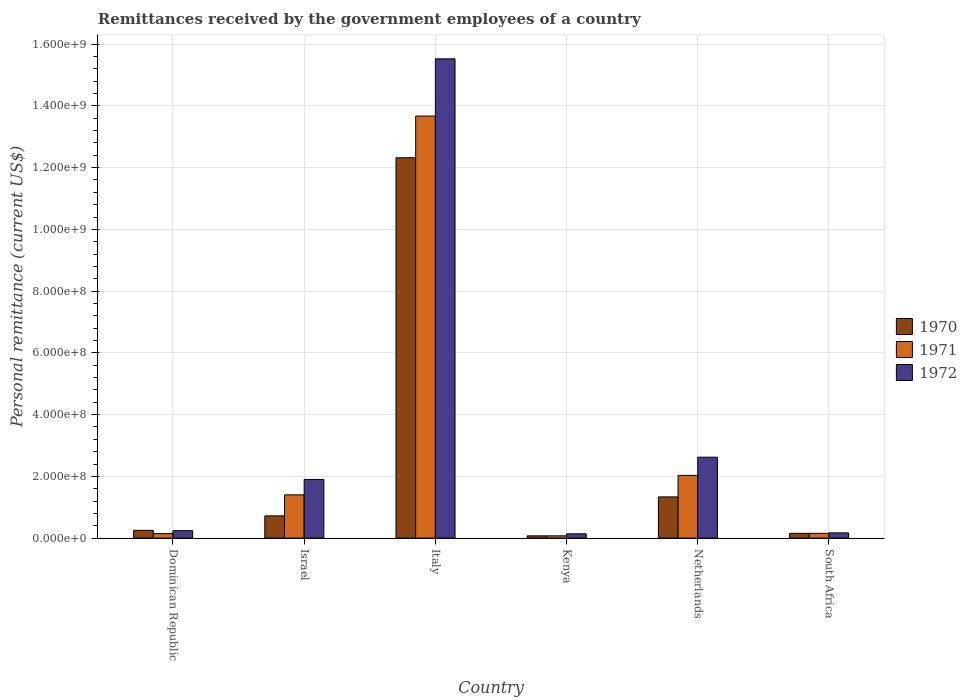How many different coloured bars are there?
Your answer should be very brief. 3. How many groups of bars are there?
Give a very brief answer. 6. Are the number of bars per tick equal to the number of legend labels?
Offer a very short reply. Yes. What is the label of the 1st group of bars from the left?
Your answer should be very brief. Dominican Republic. In how many cases, is the number of bars for a given country not equal to the number of legend labels?
Keep it short and to the point. 0. What is the remittances received by the government employees in 1972 in Israel?
Offer a very short reply. 1.90e+08. Across all countries, what is the maximum remittances received by the government employees in 1971?
Offer a very short reply. 1.37e+09. Across all countries, what is the minimum remittances received by the government employees in 1971?
Your answer should be compact. 7.26e+06. In which country was the remittances received by the government employees in 1972 maximum?
Provide a succinct answer. Italy. In which country was the remittances received by the government employees in 1970 minimum?
Ensure brevity in your answer.  Kenya. What is the total remittances received by the government employees in 1970 in the graph?
Offer a very short reply. 1.49e+09. What is the difference between the remittances received by the government employees in 1972 in Italy and that in South Africa?
Your answer should be compact. 1.54e+09. What is the difference between the remittances received by the government employees in 1970 in South Africa and the remittances received by the government employees in 1972 in Italy?
Your answer should be very brief. -1.54e+09. What is the average remittances received by the government employees in 1972 per country?
Provide a succinct answer. 3.43e+08. What is the difference between the remittances received by the government employees of/in 1971 and remittances received by the government employees of/in 1972 in South Africa?
Keep it short and to the point. -1.49e+06. In how many countries, is the remittances received by the government employees in 1970 greater than 760000000 US$?
Your answer should be very brief. 1. What is the ratio of the remittances received by the government employees in 1972 in Israel to that in Italy?
Offer a terse response. 0.12. Is the difference between the remittances received by the government employees in 1971 in Israel and Netherlands greater than the difference between the remittances received by the government employees in 1972 in Israel and Netherlands?
Make the answer very short. Yes. What is the difference between the highest and the second highest remittances received by the government employees in 1972?
Provide a succinct answer. -7.20e+07. What is the difference between the highest and the lowest remittances received by the government employees in 1971?
Make the answer very short. 1.36e+09. Is the sum of the remittances received by the government employees in 1970 in Dominican Republic and South Africa greater than the maximum remittances received by the government employees in 1971 across all countries?
Provide a short and direct response. No. Is it the case that in every country, the sum of the remittances received by the government employees in 1970 and remittances received by the government employees in 1972 is greater than the remittances received by the government employees in 1971?
Give a very brief answer. Yes. Are all the bars in the graph horizontal?
Offer a terse response. No. Does the graph contain any zero values?
Your answer should be compact. No. How many legend labels are there?
Your answer should be compact. 3. What is the title of the graph?
Make the answer very short. Remittances received by the government employees of a country. What is the label or title of the Y-axis?
Your answer should be very brief. Personal remittance (current US$). What is the Personal remittance (current US$) of 1970 in Dominican Republic?
Your answer should be compact. 2.51e+07. What is the Personal remittance (current US$) of 1971 in Dominican Republic?
Provide a succinct answer. 1.45e+07. What is the Personal remittance (current US$) in 1972 in Dominican Republic?
Provide a succinct answer. 2.40e+07. What is the Personal remittance (current US$) in 1970 in Israel?
Keep it short and to the point. 7.20e+07. What is the Personal remittance (current US$) in 1971 in Israel?
Keep it short and to the point. 1.40e+08. What is the Personal remittance (current US$) in 1972 in Israel?
Keep it short and to the point. 1.90e+08. What is the Personal remittance (current US$) in 1970 in Italy?
Offer a very short reply. 1.23e+09. What is the Personal remittance (current US$) of 1971 in Italy?
Give a very brief answer. 1.37e+09. What is the Personal remittance (current US$) of 1972 in Italy?
Provide a succinct answer. 1.55e+09. What is the Personal remittance (current US$) in 1970 in Kenya?
Ensure brevity in your answer.  7.26e+06. What is the Personal remittance (current US$) of 1971 in Kenya?
Ensure brevity in your answer.  7.26e+06. What is the Personal remittance (current US$) of 1972 in Kenya?
Offer a very short reply. 1.39e+07. What is the Personal remittance (current US$) of 1970 in Netherlands?
Your answer should be compact. 1.33e+08. What is the Personal remittance (current US$) of 1971 in Netherlands?
Offer a very short reply. 2.03e+08. What is the Personal remittance (current US$) of 1972 in Netherlands?
Provide a succinct answer. 2.62e+08. What is the Personal remittance (current US$) in 1970 in South Africa?
Keep it short and to the point. 1.54e+07. What is the Personal remittance (current US$) in 1971 in South Africa?
Your answer should be compact. 1.54e+07. What is the Personal remittance (current US$) of 1972 in South Africa?
Offer a terse response. 1.69e+07. Across all countries, what is the maximum Personal remittance (current US$) of 1970?
Make the answer very short. 1.23e+09. Across all countries, what is the maximum Personal remittance (current US$) in 1971?
Ensure brevity in your answer.  1.37e+09. Across all countries, what is the maximum Personal remittance (current US$) in 1972?
Offer a very short reply. 1.55e+09. Across all countries, what is the minimum Personal remittance (current US$) in 1970?
Give a very brief answer. 7.26e+06. Across all countries, what is the minimum Personal remittance (current US$) of 1971?
Ensure brevity in your answer.  7.26e+06. Across all countries, what is the minimum Personal remittance (current US$) in 1972?
Offer a very short reply. 1.39e+07. What is the total Personal remittance (current US$) of 1970 in the graph?
Offer a terse response. 1.49e+09. What is the total Personal remittance (current US$) of 1971 in the graph?
Provide a succinct answer. 1.75e+09. What is the total Personal remittance (current US$) of 1972 in the graph?
Provide a succinct answer. 2.06e+09. What is the difference between the Personal remittance (current US$) in 1970 in Dominican Republic and that in Israel?
Your answer should be very brief. -4.69e+07. What is the difference between the Personal remittance (current US$) of 1971 in Dominican Republic and that in Israel?
Your answer should be compact. -1.26e+08. What is the difference between the Personal remittance (current US$) in 1972 in Dominican Republic and that in Israel?
Offer a terse response. -1.66e+08. What is the difference between the Personal remittance (current US$) of 1970 in Dominican Republic and that in Italy?
Offer a terse response. -1.21e+09. What is the difference between the Personal remittance (current US$) of 1971 in Dominican Republic and that in Italy?
Provide a short and direct response. -1.35e+09. What is the difference between the Personal remittance (current US$) in 1972 in Dominican Republic and that in Italy?
Your response must be concise. -1.53e+09. What is the difference between the Personal remittance (current US$) in 1970 in Dominican Republic and that in Kenya?
Keep it short and to the point. 1.78e+07. What is the difference between the Personal remittance (current US$) in 1971 in Dominican Republic and that in Kenya?
Ensure brevity in your answer.  7.24e+06. What is the difference between the Personal remittance (current US$) of 1972 in Dominican Republic and that in Kenya?
Your answer should be very brief. 1.01e+07. What is the difference between the Personal remittance (current US$) in 1970 in Dominican Republic and that in Netherlands?
Provide a short and direct response. -1.08e+08. What is the difference between the Personal remittance (current US$) of 1971 in Dominican Republic and that in Netherlands?
Provide a succinct answer. -1.89e+08. What is the difference between the Personal remittance (current US$) in 1972 in Dominican Republic and that in Netherlands?
Keep it short and to the point. -2.38e+08. What is the difference between the Personal remittance (current US$) in 1970 in Dominican Republic and that in South Africa?
Offer a terse response. 9.70e+06. What is the difference between the Personal remittance (current US$) of 1971 in Dominican Republic and that in South Africa?
Offer a terse response. -8.78e+05. What is the difference between the Personal remittance (current US$) of 1972 in Dominican Republic and that in South Africa?
Give a very brief answer. 7.13e+06. What is the difference between the Personal remittance (current US$) of 1970 in Israel and that in Italy?
Ensure brevity in your answer.  -1.16e+09. What is the difference between the Personal remittance (current US$) of 1971 in Israel and that in Italy?
Ensure brevity in your answer.  -1.23e+09. What is the difference between the Personal remittance (current US$) of 1972 in Israel and that in Italy?
Offer a very short reply. -1.36e+09. What is the difference between the Personal remittance (current US$) in 1970 in Israel and that in Kenya?
Your answer should be very brief. 6.47e+07. What is the difference between the Personal remittance (current US$) of 1971 in Israel and that in Kenya?
Provide a succinct answer. 1.33e+08. What is the difference between the Personal remittance (current US$) in 1972 in Israel and that in Kenya?
Give a very brief answer. 1.76e+08. What is the difference between the Personal remittance (current US$) of 1970 in Israel and that in Netherlands?
Your answer should be very brief. -6.14e+07. What is the difference between the Personal remittance (current US$) in 1971 in Israel and that in Netherlands?
Your answer should be compact. -6.31e+07. What is the difference between the Personal remittance (current US$) in 1972 in Israel and that in Netherlands?
Your answer should be very brief. -7.20e+07. What is the difference between the Personal remittance (current US$) in 1970 in Israel and that in South Africa?
Offer a terse response. 5.66e+07. What is the difference between the Personal remittance (current US$) in 1971 in Israel and that in South Africa?
Provide a succinct answer. 1.25e+08. What is the difference between the Personal remittance (current US$) of 1972 in Israel and that in South Africa?
Offer a very short reply. 1.73e+08. What is the difference between the Personal remittance (current US$) in 1970 in Italy and that in Kenya?
Your answer should be compact. 1.22e+09. What is the difference between the Personal remittance (current US$) of 1971 in Italy and that in Kenya?
Give a very brief answer. 1.36e+09. What is the difference between the Personal remittance (current US$) of 1972 in Italy and that in Kenya?
Your answer should be very brief. 1.54e+09. What is the difference between the Personal remittance (current US$) in 1970 in Italy and that in Netherlands?
Your answer should be very brief. 1.10e+09. What is the difference between the Personal remittance (current US$) in 1971 in Italy and that in Netherlands?
Your answer should be very brief. 1.16e+09. What is the difference between the Personal remittance (current US$) of 1972 in Italy and that in Netherlands?
Your response must be concise. 1.29e+09. What is the difference between the Personal remittance (current US$) in 1970 in Italy and that in South Africa?
Your response must be concise. 1.22e+09. What is the difference between the Personal remittance (current US$) of 1971 in Italy and that in South Africa?
Provide a short and direct response. 1.35e+09. What is the difference between the Personal remittance (current US$) in 1972 in Italy and that in South Africa?
Offer a very short reply. 1.54e+09. What is the difference between the Personal remittance (current US$) of 1970 in Kenya and that in Netherlands?
Offer a very short reply. -1.26e+08. What is the difference between the Personal remittance (current US$) of 1971 in Kenya and that in Netherlands?
Offer a terse response. -1.96e+08. What is the difference between the Personal remittance (current US$) of 1972 in Kenya and that in Netherlands?
Give a very brief answer. -2.48e+08. What is the difference between the Personal remittance (current US$) in 1970 in Kenya and that in South Africa?
Offer a very short reply. -8.14e+06. What is the difference between the Personal remittance (current US$) in 1971 in Kenya and that in South Africa?
Make the answer very short. -8.12e+06. What is the difference between the Personal remittance (current US$) of 1972 in Kenya and that in South Africa?
Keep it short and to the point. -3.01e+06. What is the difference between the Personal remittance (current US$) in 1970 in Netherlands and that in South Africa?
Your response must be concise. 1.18e+08. What is the difference between the Personal remittance (current US$) of 1971 in Netherlands and that in South Africa?
Keep it short and to the point. 1.88e+08. What is the difference between the Personal remittance (current US$) of 1972 in Netherlands and that in South Africa?
Give a very brief answer. 2.45e+08. What is the difference between the Personal remittance (current US$) in 1970 in Dominican Republic and the Personal remittance (current US$) in 1971 in Israel?
Provide a succinct answer. -1.15e+08. What is the difference between the Personal remittance (current US$) of 1970 in Dominican Republic and the Personal remittance (current US$) of 1972 in Israel?
Ensure brevity in your answer.  -1.65e+08. What is the difference between the Personal remittance (current US$) in 1971 in Dominican Republic and the Personal remittance (current US$) in 1972 in Israel?
Your answer should be compact. -1.76e+08. What is the difference between the Personal remittance (current US$) of 1970 in Dominican Republic and the Personal remittance (current US$) of 1971 in Italy?
Offer a terse response. -1.34e+09. What is the difference between the Personal remittance (current US$) of 1970 in Dominican Republic and the Personal remittance (current US$) of 1972 in Italy?
Provide a short and direct response. -1.53e+09. What is the difference between the Personal remittance (current US$) of 1971 in Dominican Republic and the Personal remittance (current US$) of 1972 in Italy?
Your answer should be very brief. -1.54e+09. What is the difference between the Personal remittance (current US$) of 1970 in Dominican Republic and the Personal remittance (current US$) of 1971 in Kenya?
Ensure brevity in your answer.  1.78e+07. What is the difference between the Personal remittance (current US$) in 1970 in Dominican Republic and the Personal remittance (current US$) in 1972 in Kenya?
Keep it short and to the point. 1.12e+07. What is the difference between the Personal remittance (current US$) in 1971 in Dominican Republic and the Personal remittance (current US$) in 1972 in Kenya?
Offer a very short reply. 6.40e+05. What is the difference between the Personal remittance (current US$) in 1970 in Dominican Republic and the Personal remittance (current US$) in 1971 in Netherlands?
Your response must be concise. -1.78e+08. What is the difference between the Personal remittance (current US$) of 1970 in Dominican Republic and the Personal remittance (current US$) of 1972 in Netherlands?
Offer a very short reply. -2.37e+08. What is the difference between the Personal remittance (current US$) of 1971 in Dominican Republic and the Personal remittance (current US$) of 1972 in Netherlands?
Provide a short and direct response. -2.48e+08. What is the difference between the Personal remittance (current US$) in 1970 in Dominican Republic and the Personal remittance (current US$) in 1971 in South Africa?
Keep it short and to the point. 9.72e+06. What is the difference between the Personal remittance (current US$) of 1970 in Dominican Republic and the Personal remittance (current US$) of 1972 in South Africa?
Keep it short and to the point. 8.23e+06. What is the difference between the Personal remittance (current US$) of 1971 in Dominican Republic and the Personal remittance (current US$) of 1972 in South Africa?
Offer a terse response. -2.37e+06. What is the difference between the Personal remittance (current US$) in 1970 in Israel and the Personal remittance (current US$) in 1971 in Italy?
Offer a terse response. -1.30e+09. What is the difference between the Personal remittance (current US$) of 1970 in Israel and the Personal remittance (current US$) of 1972 in Italy?
Offer a terse response. -1.48e+09. What is the difference between the Personal remittance (current US$) of 1971 in Israel and the Personal remittance (current US$) of 1972 in Italy?
Ensure brevity in your answer.  -1.41e+09. What is the difference between the Personal remittance (current US$) of 1970 in Israel and the Personal remittance (current US$) of 1971 in Kenya?
Offer a very short reply. 6.47e+07. What is the difference between the Personal remittance (current US$) in 1970 in Israel and the Personal remittance (current US$) in 1972 in Kenya?
Offer a terse response. 5.81e+07. What is the difference between the Personal remittance (current US$) in 1971 in Israel and the Personal remittance (current US$) in 1972 in Kenya?
Your answer should be compact. 1.26e+08. What is the difference between the Personal remittance (current US$) in 1970 in Israel and the Personal remittance (current US$) in 1971 in Netherlands?
Offer a terse response. -1.31e+08. What is the difference between the Personal remittance (current US$) in 1970 in Israel and the Personal remittance (current US$) in 1972 in Netherlands?
Offer a very short reply. -1.90e+08. What is the difference between the Personal remittance (current US$) of 1971 in Israel and the Personal remittance (current US$) of 1972 in Netherlands?
Provide a short and direct response. -1.22e+08. What is the difference between the Personal remittance (current US$) of 1970 in Israel and the Personal remittance (current US$) of 1971 in South Africa?
Your answer should be very brief. 5.66e+07. What is the difference between the Personal remittance (current US$) in 1970 in Israel and the Personal remittance (current US$) in 1972 in South Africa?
Your answer should be compact. 5.51e+07. What is the difference between the Personal remittance (current US$) in 1971 in Israel and the Personal remittance (current US$) in 1972 in South Africa?
Offer a terse response. 1.23e+08. What is the difference between the Personal remittance (current US$) in 1970 in Italy and the Personal remittance (current US$) in 1971 in Kenya?
Your response must be concise. 1.22e+09. What is the difference between the Personal remittance (current US$) of 1970 in Italy and the Personal remittance (current US$) of 1972 in Kenya?
Keep it short and to the point. 1.22e+09. What is the difference between the Personal remittance (current US$) in 1971 in Italy and the Personal remittance (current US$) in 1972 in Kenya?
Your answer should be compact. 1.35e+09. What is the difference between the Personal remittance (current US$) in 1970 in Italy and the Personal remittance (current US$) in 1971 in Netherlands?
Keep it short and to the point. 1.03e+09. What is the difference between the Personal remittance (current US$) of 1970 in Italy and the Personal remittance (current US$) of 1972 in Netherlands?
Offer a very short reply. 9.70e+08. What is the difference between the Personal remittance (current US$) in 1971 in Italy and the Personal remittance (current US$) in 1972 in Netherlands?
Offer a very short reply. 1.10e+09. What is the difference between the Personal remittance (current US$) in 1970 in Italy and the Personal remittance (current US$) in 1971 in South Africa?
Provide a short and direct response. 1.22e+09. What is the difference between the Personal remittance (current US$) of 1970 in Italy and the Personal remittance (current US$) of 1972 in South Africa?
Provide a succinct answer. 1.22e+09. What is the difference between the Personal remittance (current US$) in 1971 in Italy and the Personal remittance (current US$) in 1972 in South Africa?
Make the answer very short. 1.35e+09. What is the difference between the Personal remittance (current US$) of 1970 in Kenya and the Personal remittance (current US$) of 1971 in Netherlands?
Your answer should be very brief. -1.96e+08. What is the difference between the Personal remittance (current US$) of 1970 in Kenya and the Personal remittance (current US$) of 1972 in Netherlands?
Offer a very short reply. -2.55e+08. What is the difference between the Personal remittance (current US$) in 1971 in Kenya and the Personal remittance (current US$) in 1972 in Netherlands?
Ensure brevity in your answer.  -2.55e+08. What is the difference between the Personal remittance (current US$) of 1970 in Kenya and the Personal remittance (current US$) of 1971 in South Africa?
Provide a short and direct response. -8.12e+06. What is the difference between the Personal remittance (current US$) in 1970 in Kenya and the Personal remittance (current US$) in 1972 in South Africa?
Keep it short and to the point. -9.61e+06. What is the difference between the Personal remittance (current US$) in 1971 in Kenya and the Personal remittance (current US$) in 1972 in South Africa?
Make the answer very short. -9.61e+06. What is the difference between the Personal remittance (current US$) of 1970 in Netherlands and the Personal remittance (current US$) of 1971 in South Africa?
Keep it short and to the point. 1.18e+08. What is the difference between the Personal remittance (current US$) in 1970 in Netherlands and the Personal remittance (current US$) in 1972 in South Africa?
Provide a succinct answer. 1.17e+08. What is the difference between the Personal remittance (current US$) in 1971 in Netherlands and the Personal remittance (current US$) in 1972 in South Africa?
Give a very brief answer. 1.86e+08. What is the average Personal remittance (current US$) of 1970 per country?
Your answer should be compact. 2.48e+08. What is the average Personal remittance (current US$) of 1971 per country?
Offer a very short reply. 2.91e+08. What is the average Personal remittance (current US$) in 1972 per country?
Give a very brief answer. 3.43e+08. What is the difference between the Personal remittance (current US$) of 1970 and Personal remittance (current US$) of 1971 in Dominican Republic?
Your response must be concise. 1.06e+07. What is the difference between the Personal remittance (current US$) in 1970 and Personal remittance (current US$) in 1972 in Dominican Republic?
Your answer should be very brief. 1.10e+06. What is the difference between the Personal remittance (current US$) in 1971 and Personal remittance (current US$) in 1972 in Dominican Republic?
Ensure brevity in your answer.  -9.50e+06. What is the difference between the Personal remittance (current US$) in 1970 and Personal remittance (current US$) in 1971 in Israel?
Keep it short and to the point. -6.80e+07. What is the difference between the Personal remittance (current US$) of 1970 and Personal remittance (current US$) of 1972 in Israel?
Ensure brevity in your answer.  -1.18e+08. What is the difference between the Personal remittance (current US$) of 1971 and Personal remittance (current US$) of 1972 in Israel?
Your response must be concise. -5.00e+07. What is the difference between the Personal remittance (current US$) of 1970 and Personal remittance (current US$) of 1971 in Italy?
Keep it short and to the point. -1.35e+08. What is the difference between the Personal remittance (current US$) in 1970 and Personal remittance (current US$) in 1972 in Italy?
Make the answer very short. -3.20e+08. What is the difference between the Personal remittance (current US$) in 1971 and Personal remittance (current US$) in 1972 in Italy?
Provide a succinct answer. -1.85e+08. What is the difference between the Personal remittance (current US$) in 1970 and Personal remittance (current US$) in 1972 in Kenya?
Your answer should be very brief. -6.60e+06. What is the difference between the Personal remittance (current US$) in 1971 and Personal remittance (current US$) in 1972 in Kenya?
Your answer should be very brief. -6.60e+06. What is the difference between the Personal remittance (current US$) of 1970 and Personal remittance (current US$) of 1971 in Netherlands?
Make the answer very short. -6.97e+07. What is the difference between the Personal remittance (current US$) of 1970 and Personal remittance (current US$) of 1972 in Netherlands?
Offer a very short reply. -1.29e+08. What is the difference between the Personal remittance (current US$) in 1971 and Personal remittance (current US$) in 1972 in Netherlands?
Offer a terse response. -5.89e+07. What is the difference between the Personal remittance (current US$) of 1970 and Personal remittance (current US$) of 1971 in South Africa?
Make the answer very short. 2.18e+04. What is the difference between the Personal remittance (current US$) of 1970 and Personal remittance (current US$) of 1972 in South Africa?
Ensure brevity in your answer.  -1.47e+06. What is the difference between the Personal remittance (current US$) of 1971 and Personal remittance (current US$) of 1972 in South Africa?
Offer a terse response. -1.49e+06. What is the ratio of the Personal remittance (current US$) of 1970 in Dominican Republic to that in Israel?
Give a very brief answer. 0.35. What is the ratio of the Personal remittance (current US$) in 1971 in Dominican Republic to that in Israel?
Offer a very short reply. 0.1. What is the ratio of the Personal remittance (current US$) of 1972 in Dominican Republic to that in Israel?
Keep it short and to the point. 0.13. What is the ratio of the Personal remittance (current US$) in 1970 in Dominican Republic to that in Italy?
Give a very brief answer. 0.02. What is the ratio of the Personal remittance (current US$) in 1971 in Dominican Republic to that in Italy?
Keep it short and to the point. 0.01. What is the ratio of the Personal remittance (current US$) in 1972 in Dominican Republic to that in Italy?
Ensure brevity in your answer.  0.02. What is the ratio of the Personal remittance (current US$) of 1970 in Dominican Republic to that in Kenya?
Your answer should be very brief. 3.46. What is the ratio of the Personal remittance (current US$) in 1971 in Dominican Republic to that in Kenya?
Give a very brief answer. 2. What is the ratio of the Personal remittance (current US$) in 1972 in Dominican Republic to that in Kenya?
Provide a succinct answer. 1.73. What is the ratio of the Personal remittance (current US$) in 1970 in Dominican Republic to that in Netherlands?
Your answer should be very brief. 0.19. What is the ratio of the Personal remittance (current US$) in 1971 in Dominican Republic to that in Netherlands?
Your answer should be compact. 0.07. What is the ratio of the Personal remittance (current US$) of 1972 in Dominican Republic to that in Netherlands?
Give a very brief answer. 0.09. What is the ratio of the Personal remittance (current US$) of 1970 in Dominican Republic to that in South Africa?
Your answer should be compact. 1.63. What is the ratio of the Personal remittance (current US$) of 1971 in Dominican Republic to that in South Africa?
Offer a very short reply. 0.94. What is the ratio of the Personal remittance (current US$) in 1972 in Dominican Republic to that in South Africa?
Ensure brevity in your answer.  1.42. What is the ratio of the Personal remittance (current US$) of 1970 in Israel to that in Italy?
Ensure brevity in your answer.  0.06. What is the ratio of the Personal remittance (current US$) of 1971 in Israel to that in Italy?
Your answer should be compact. 0.1. What is the ratio of the Personal remittance (current US$) of 1972 in Israel to that in Italy?
Provide a short and direct response. 0.12. What is the ratio of the Personal remittance (current US$) in 1970 in Israel to that in Kenya?
Make the answer very short. 9.92. What is the ratio of the Personal remittance (current US$) of 1971 in Israel to that in Kenya?
Provide a succinct answer. 19.28. What is the ratio of the Personal remittance (current US$) in 1972 in Israel to that in Kenya?
Make the answer very short. 13.71. What is the ratio of the Personal remittance (current US$) in 1970 in Israel to that in Netherlands?
Give a very brief answer. 0.54. What is the ratio of the Personal remittance (current US$) in 1971 in Israel to that in Netherlands?
Offer a very short reply. 0.69. What is the ratio of the Personal remittance (current US$) in 1972 in Israel to that in Netherlands?
Provide a succinct answer. 0.73. What is the ratio of the Personal remittance (current US$) of 1970 in Israel to that in South Africa?
Your response must be concise. 4.68. What is the ratio of the Personal remittance (current US$) in 1971 in Israel to that in South Africa?
Your answer should be compact. 9.1. What is the ratio of the Personal remittance (current US$) in 1972 in Israel to that in South Africa?
Ensure brevity in your answer.  11.26. What is the ratio of the Personal remittance (current US$) in 1970 in Italy to that in Kenya?
Your answer should be compact. 169.7. What is the ratio of the Personal remittance (current US$) of 1971 in Italy to that in Kenya?
Your response must be concise. 188.29. What is the ratio of the Personal remittance (current US$) of 1972 in Italy to that in Kenya?
Provide a succinct answer. 112.01. What is the ratio of the Personal remittance (current US$) in 1970 in Italy to that in Netherlands?
Offer a very short reply. 9.23. What is the ratio of the Personal remittance (current US$) in 1971 in Italy to that in Netherlands?
Keep it short and to the point. 6.73. What is the ratio of the Personal remittance (current US$) of 1972 in Italy to that in Netherlands?
Make the answer very short. 5.92. What is the ratio of the Personal remittance (current US$) in 1971 in Italy to that in South Africa?
Keep it short and to the point. 88.89. What is the ratio of the Personal remittance (current US$) of 1972 in Italy to that in South Africa?
Keep it short and to the point. 92.01. What is the ratio of the Personal remittance (current US$) in 1970 in Kenya to that in Netherlands?
Provide a succinct answer. 0.05. What is the ratio of the Personal remittance (current US$) in 1971 in Kenya to that in Netherlands?
Offer a terse response. 0.04. What is the ratio of the Personal remittance (current US$) in 1972 in Kenya to that in Netherlands?
Offer a terse response. 0.05. What is the ratio of the Personal remittance (current US$) of 1970 in Kenya to that in South Africa?
Offer a very short reply. 0.47. What is the ratio of the Personal remittance (current US$) in 1971 in Kenya to that in South Africa?
Your answer should be very brief. 0.47. What is the ratio of the Personal remittance (current US$) in 1972 in Kenya to that in South Africa?
Make the answer very short. 0.82. What is the ratio of the Personal remittance (current US$) in 1970 in Netherlands to that in South Africa?
Provide a short and direct response. 8.66. What is the ratio of the Personal remittance (current US$) in 1971 in Netherlands to that in South Africa?
Your response must be concise. 13.21. What is the ratio of the Personal remittance (current US$) in 1972 in Netherlands to that in South Africa?
Your response must be concise. 15.53. What is the difference between the highest and the second highest Personal remittance (current US$) in 1970?
Ensure brevity in your answer.  1.10e+09. What is the difference between the highest and the second highest Personal remittance (current US$) of 1971?
Your response must be concise. 1.16e+09. What is the difference between the highest and the second highest Personal remittance (current US$) in 1972?
Give a very brief answer. 1.29e+09. What is the difference between the highest and the lowest Personal remittance (current US$) of 1970?
Offer a terse response. 1.22e+09. What is the difference between the highest and the lowest Personal remittance (current US$) of 1971?
Ensure brevity in your answer.  1.36e+09. What is the difference between the highest and the lowest Personal remittance (current US$) of 1972?
Provide a succinct answer. 1.54e+09. 